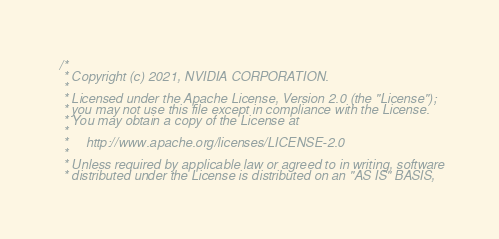<code> <loc_0><loc_0><loc_500><loc_500><_Cuda_>/*
 * Copyright (c) 2021, NVIDIA CORPORATION.
 *
 * Licensed under the Apache License, Version 2.0 (the "License");
 * you may not use this file except in compliance with the License.
 * You may obtain a copy of the License at
 *
 *     http://www.apache.org/licenses/LICENSE-2.0
 *
 * Unless required by applicable law or agreed to in writing, software
 * distributed under the License is distributed on an "AS IS" BASIS,</code> 